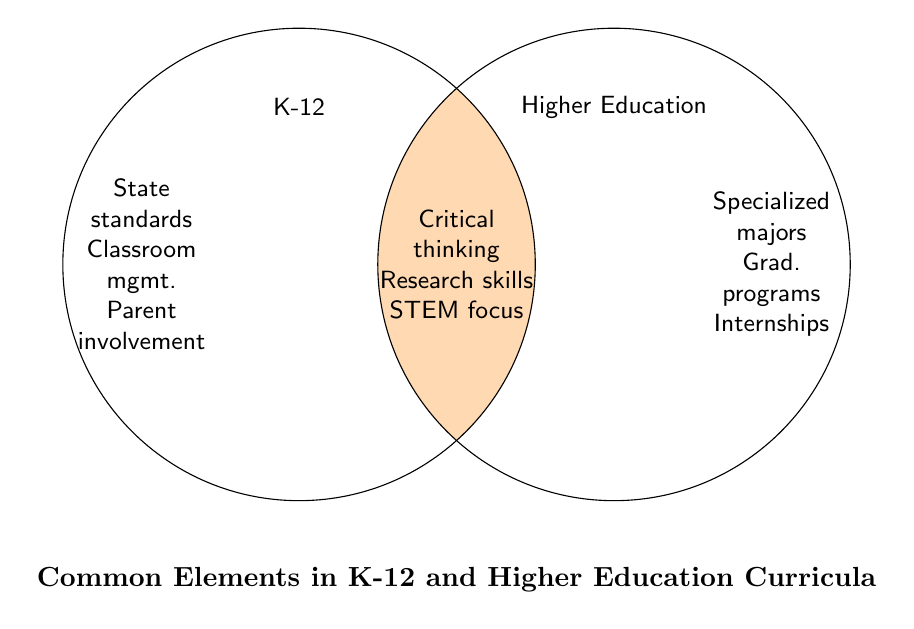What are three elements found exclusively in K-12 curricula? The left section of the Venn Diagram contains elements exclusive to K-12 curricula, such as State standards, Classroom management, and Parent involvement
Answer: State standards, Classroom management, Parent involvement Which curriculum area focuses on "Graduate programs"? The right section of the Venn Diagram is designated for elements exclusive to higher education, and "Graduate programs" is listed there
Answer: Higher education What are the common elements in both K-12 and higher education curricula? The overlapping center section of the Venn Diagram lists the common elements, including Critical thinking, Research skills, and STEM focus
Answer: Critical thinking, Research skills, STEM focus How many elements are there in the overlap between K-12 and higher education curricula? Counting the items in the center overlapping section of the Venn Diagram gives the number of common elements
Answer: 3 Which section includes "Extracurricular activities"? The left section of the Venn Diagram, designated for K-12 elements, contains "Extracurricular activities"
Answer: K-12 What is the only element related to digital literacy? The overlapping section shows "Digital literacy" as a common element in both K-12 and higher education curricula
Answer: Both Can you find more elements in the K-12 or higher education exclusive sections? Counting the elements in each exclusive section: K-12 has 5 elements, and higher education has 6 elements
Answer: Higher education Is "Information literacy" included in K-12, higher education, or both? The overlapping center section lists "Information literacy" as common to both K-12 and higher education
Answer: Both What educational level includes "Seminar discussions"? The right section lists "Seminar discussions", indicating it is part of the higher education curriculum
Answer: Higher education 